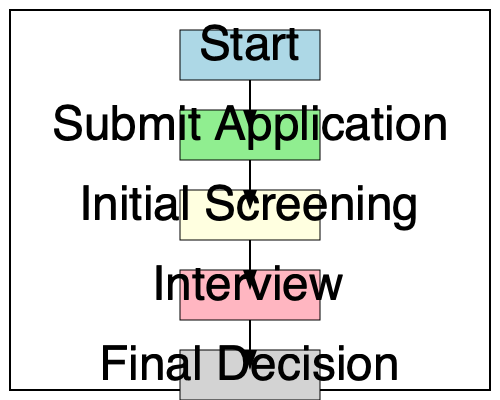Based on the flowchart, which step immediately follows the "Initial Screening" stage in the application process? To answer this question, we need to follow the steps in the flowchart:

1. The flowchart starts with the "Start" box at the top.
2. It then moves down to "Submit Application".
3. After submitting the application, the next step is "Initial Screening".
4. Following the arrow from "Initial Screening", we can see that it leads directly to the "Interview" stage.
5. The final step in the process is "Final Decision".

Therefore, the step that immediately follows the "Initial Screening" stage is the "Interview" stage.
Answer: Interview 